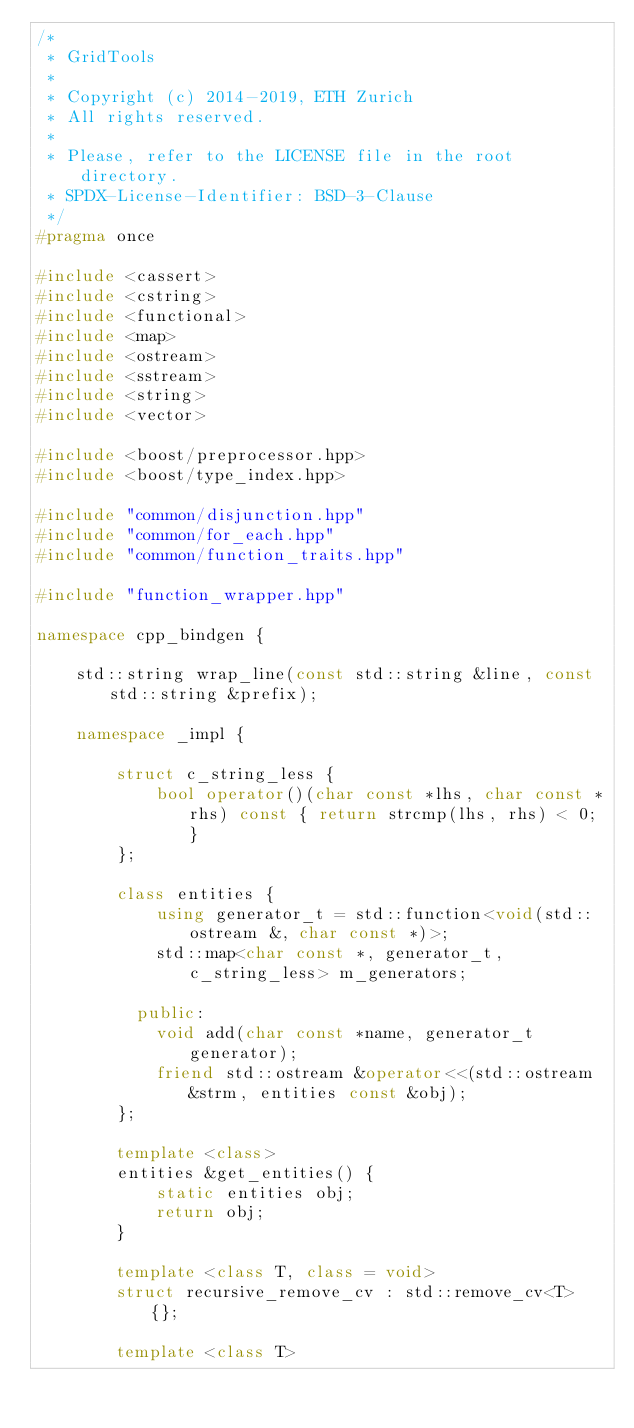Convert code to text. <code><loc_0><loc_0><loc_500><loc_500><_C++_>/*
 * GridTools
 *
 * Copyright (c) 2014-2019, ETH Zurich
 * All rights reserved.
 *
 * Please, refer to the LICENSE file in the root directory.
 * SPDX-License-Identifier: BSD-3-Clause
 */
#pragma once

#include <cassert>
#include <cstring>
#include <functional>
#include <map>
#include <ostream>
#include <sstream>
#include <string>
#include <vector>

#include <boost/preprocessor.hpp>
#include <boost/type_index.hpp>

#include "common/disjunction.hpp"
#include "common/for_each.hpp"
#include "common/function_traits.hpp"

#include "function_wrapper.hpp"

namespace cpp_bindgen {

    std::string wrap_line(const std::string &line, const std::string &prefix);

    namespace _impl {

        struct c_string_less {
            bool operator()(char const *lhs, char const *rhs) const { return strcmp(lhs, rhs) < 0; }
        };

        class entities {
            using generator_t = std::function<void(std::ostream &, char const *)>;
            std::map<char const *, generator_t, c_string_less> m_generators;

          public:
            void add(char const *name, generator_t generator);
            friend std::ostream &operator<<(std::ostream &strm, entities const &obj);
        };

        template <class>
        entities &get_entities() {
            static entities obj;
            return obj;
        }

        template <class T, class = void>
        struct recursive_remove_cv : std::remove_cv<T> {};

        template <class T></code> 